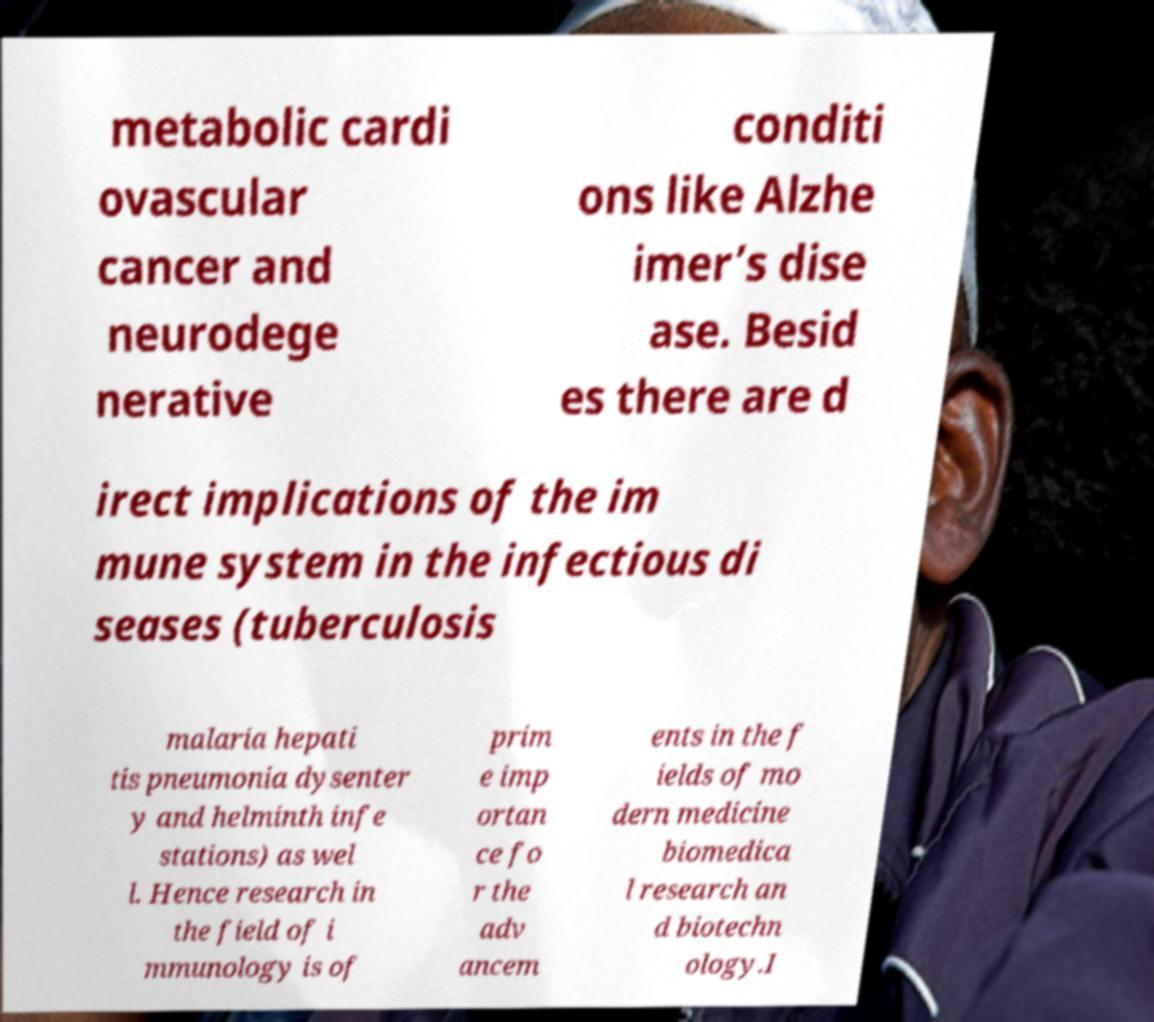I need the written content from this picture converted into text. Can you do that? metabolic cardi ovascular cancer and neurodege nerative conditi ons like Alzhe imer’s dise ase. Besid es there are d irect implications of the im mune system in the infectious di seases (tuberculosis malaria hepati tis pneumonia dysenter y and helminth infe stations) as wel l. Hence research in the field of i mmunology is of prim e imp ortan ce fo r the adv ancem ents in the f ields of mo dern medicine biomedica l research an d biotechn ology.I 